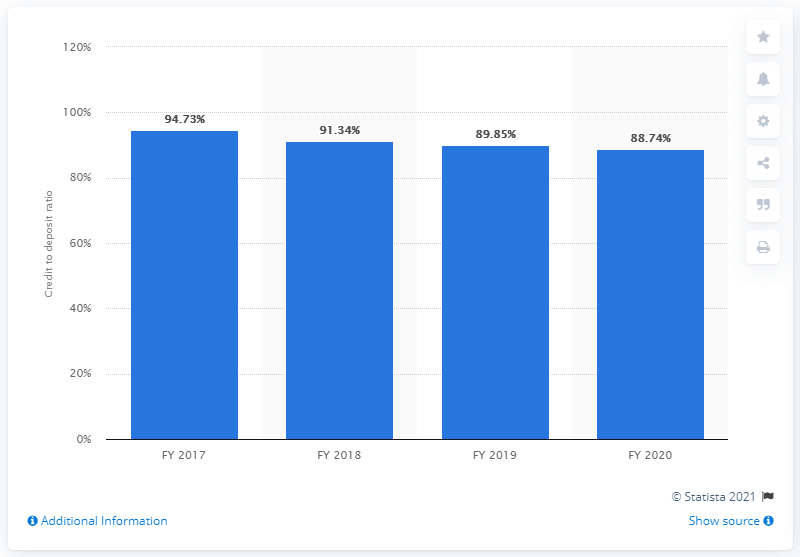Specify some key components in this picture. In the fiscal year 2020, ICICI Bank's credit to deposit ratio was 88.74, which indicates that the bank lent 88.74 rupees for every 100 rupees deposited by its customers. 